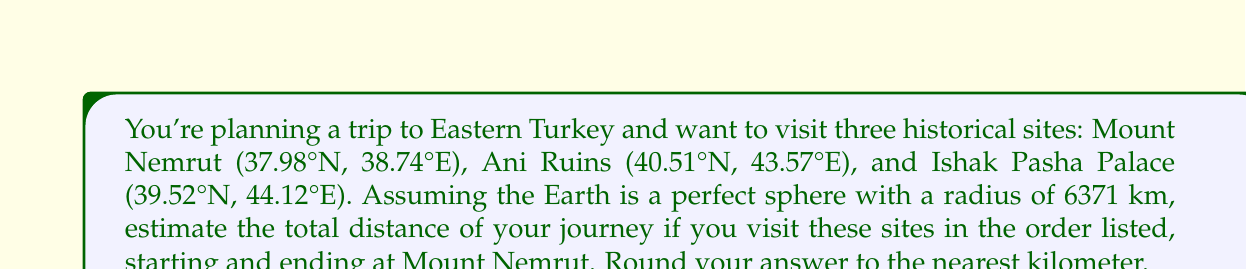Show me your answer to this math problem. To solve this problem, we'll use the Haversine formula to calculate the great-circle distance between each pair of coordinates. The formula is:

$$d = 2r \arcsin\left(\sqrt{\sin^2\left(\frac{\phi_2 - \phi_1}{2}\right) + \cos(\phi_1)\cos(\phi_2)\sin^2\left(\frac{\lambda_2 - \lambda_1}{2}\right)}\right)$$

Where:
$d$ is the distance between two points on a sphere
$r$ is the radius of the sphere (in this case, 6371 km)
$\phi_1, \phi_2$ are the latitudes of point 1 and point 2 in radians
$\lambda_1, \lambda_2$ are the longitudes of point 1 and point 2 in radians

Step 1: Convert all coordinates from degrees to radians
Mount Nemrut: $(37.98° \cdot \frac{\pi}{180}, 38.74° \cdot \frac{\pi}{180}) = (0.6629, 0.6762)$
Ani Ruins: $(40.51° \cdot \frac{\pi}{180}, 43.57° \cdot \frac{\pi}{180}) = (0.7070, 0.7605)$
Ishak Pasha Palace: $(39.52° \cdot \frac{\pi}{180}, 44.12° \cdot \frac{\pi}{180}) = (0.6899, 0.7701)$

Step 2: Calculate distances between each pair of sites
Mount Nemrut to Ani Ruins:
$$d_1 = 2 \cdot 6371 \cdot \arcsin\left(\sqrt{\sin^2\left(\frac{0.7070 - 0.6629}{2}\right) + \cos(0.6629)\cos(0.7070)\sin^2\left(\frac{0.7605 - 0.6762}{2}\right)}\right) = 509.7 \text{ km}$$

Ani Ruins to Ishak Pasha Palace:
$$d_2 = 2 \cdot 6371 \cdot \arcsin\left(\sqrt{\sin^2\left(\frac{0.6899 - 0.7070}{2}\right) + \cos(0.7070)\cos(0.6899)\sin^2\left(\frac{0.7701 - 0.7605}{2}\right)}\right) = 116.7 \text{ km}$$

Ishak Pasha Palace to Mount Nemrut:
$$d_3 = 2 \cdot 6371 \cdot \arcsin\left(\sqrt{\sin^2\left(\frac{0.6629 - 0.6899}{2}\right) + \cos(0.6899)\cos(0.6629)\sin^2\left(\frac{0.6762 - 0.7701}{2}\right)}\right) = 453.9 \text{ km}$$

Step 3: Sum up the total distance
Total distance = $d_1 + d_2 + d_3 = 509.7 + 116.7 + 453.9 = 1080.3 \text{ km}$

Step 4: Round to the nearest kilometer
1080 km
Answer: 1080 km 